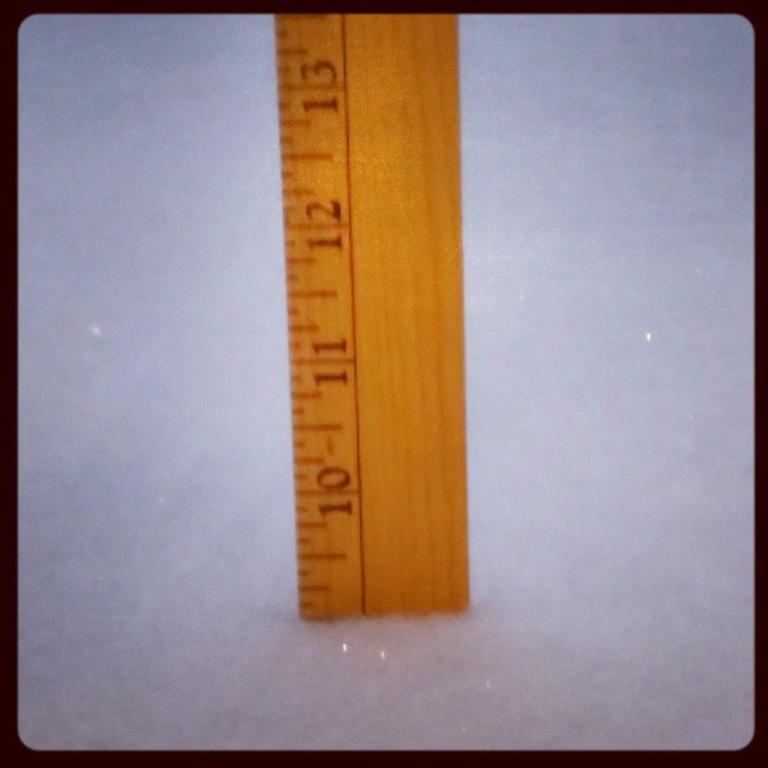<image>
Offer a succinct explanation of the picture presented. A ruler sitting in a snowbank with the snow up to the 9 inch level. 